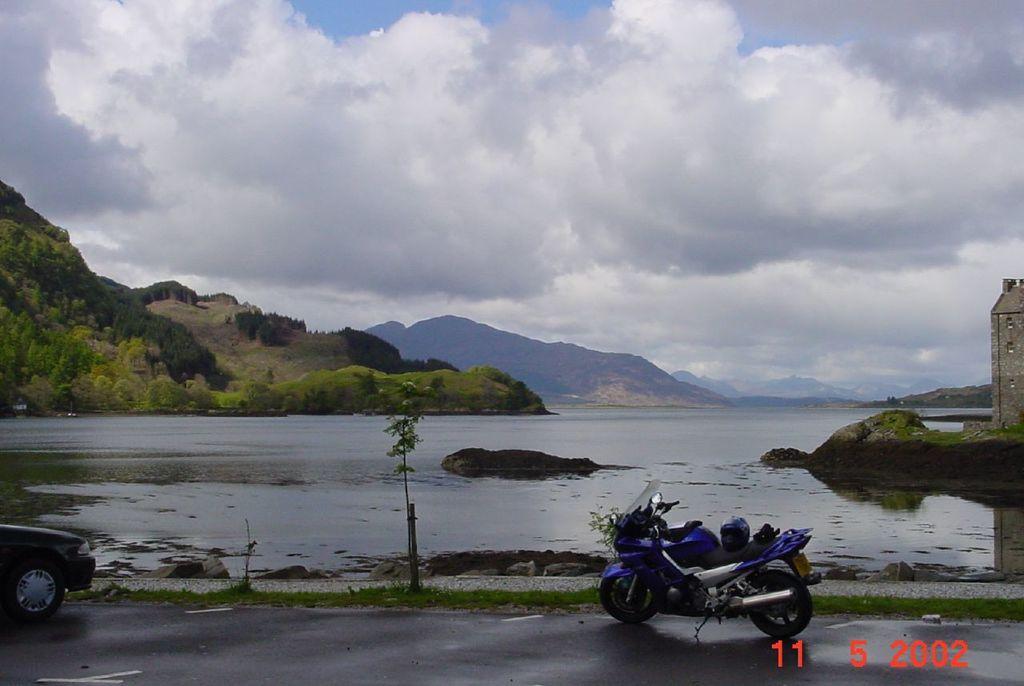Can you describe this image briefly? In this image we can see a motor vehicle and a car on the road. We can also see some grass, a plant, the rock, a large water body, a building, a group of trees on the hills and the sky which looks cloudy. 